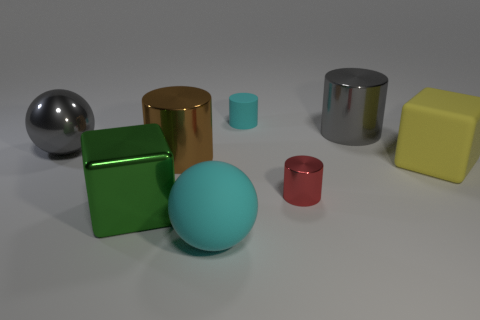Subtract all small red metallic cylinders. How many cylinders are left? 3 Add 2 big shiny balls. How many objects exist? 10 Subtract all gray cylinders. How many cylinders are left? 3 Subtract 1 blocks. How many blocks are left? 1 Add 5 large gray cylinders. How many large gray cylinders are left? 6 Add 8 brown matte cylinders. How many brown matte cylinders exist? 8 Subtract 1 cyan balls. How many objects are left? 7 Subtract all blocks. How many objects are left? 6 Subtract all purple spheres. Subtract all green cubes. How many spheres are left? 2 Subtract all red metal cylinders. Subtract all big red rubber spheres. How many objects are left? 7 